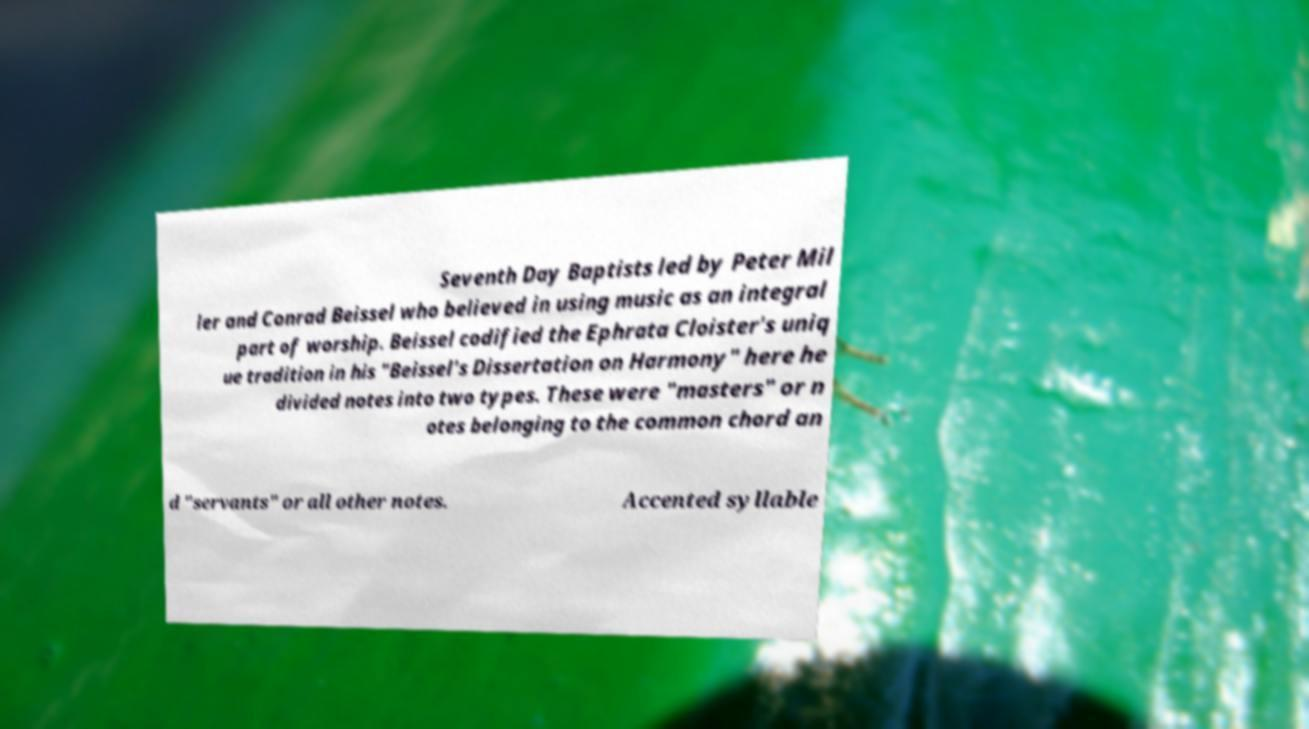I need the written content from this picture converted into text. Can you do that? Seventh Day Baptists led by Peter Mil ler and Conrad Beissel who believed in using music as an integral part of worship. Beissel codified the Ephrata Cloister's uniq ue tradition in his "Beissel's Dissertation on Harmony" here he divided notes into two types. These were "masters" or n otes belonging to the common chord an d "servants" or all other notes. Accented syllable 